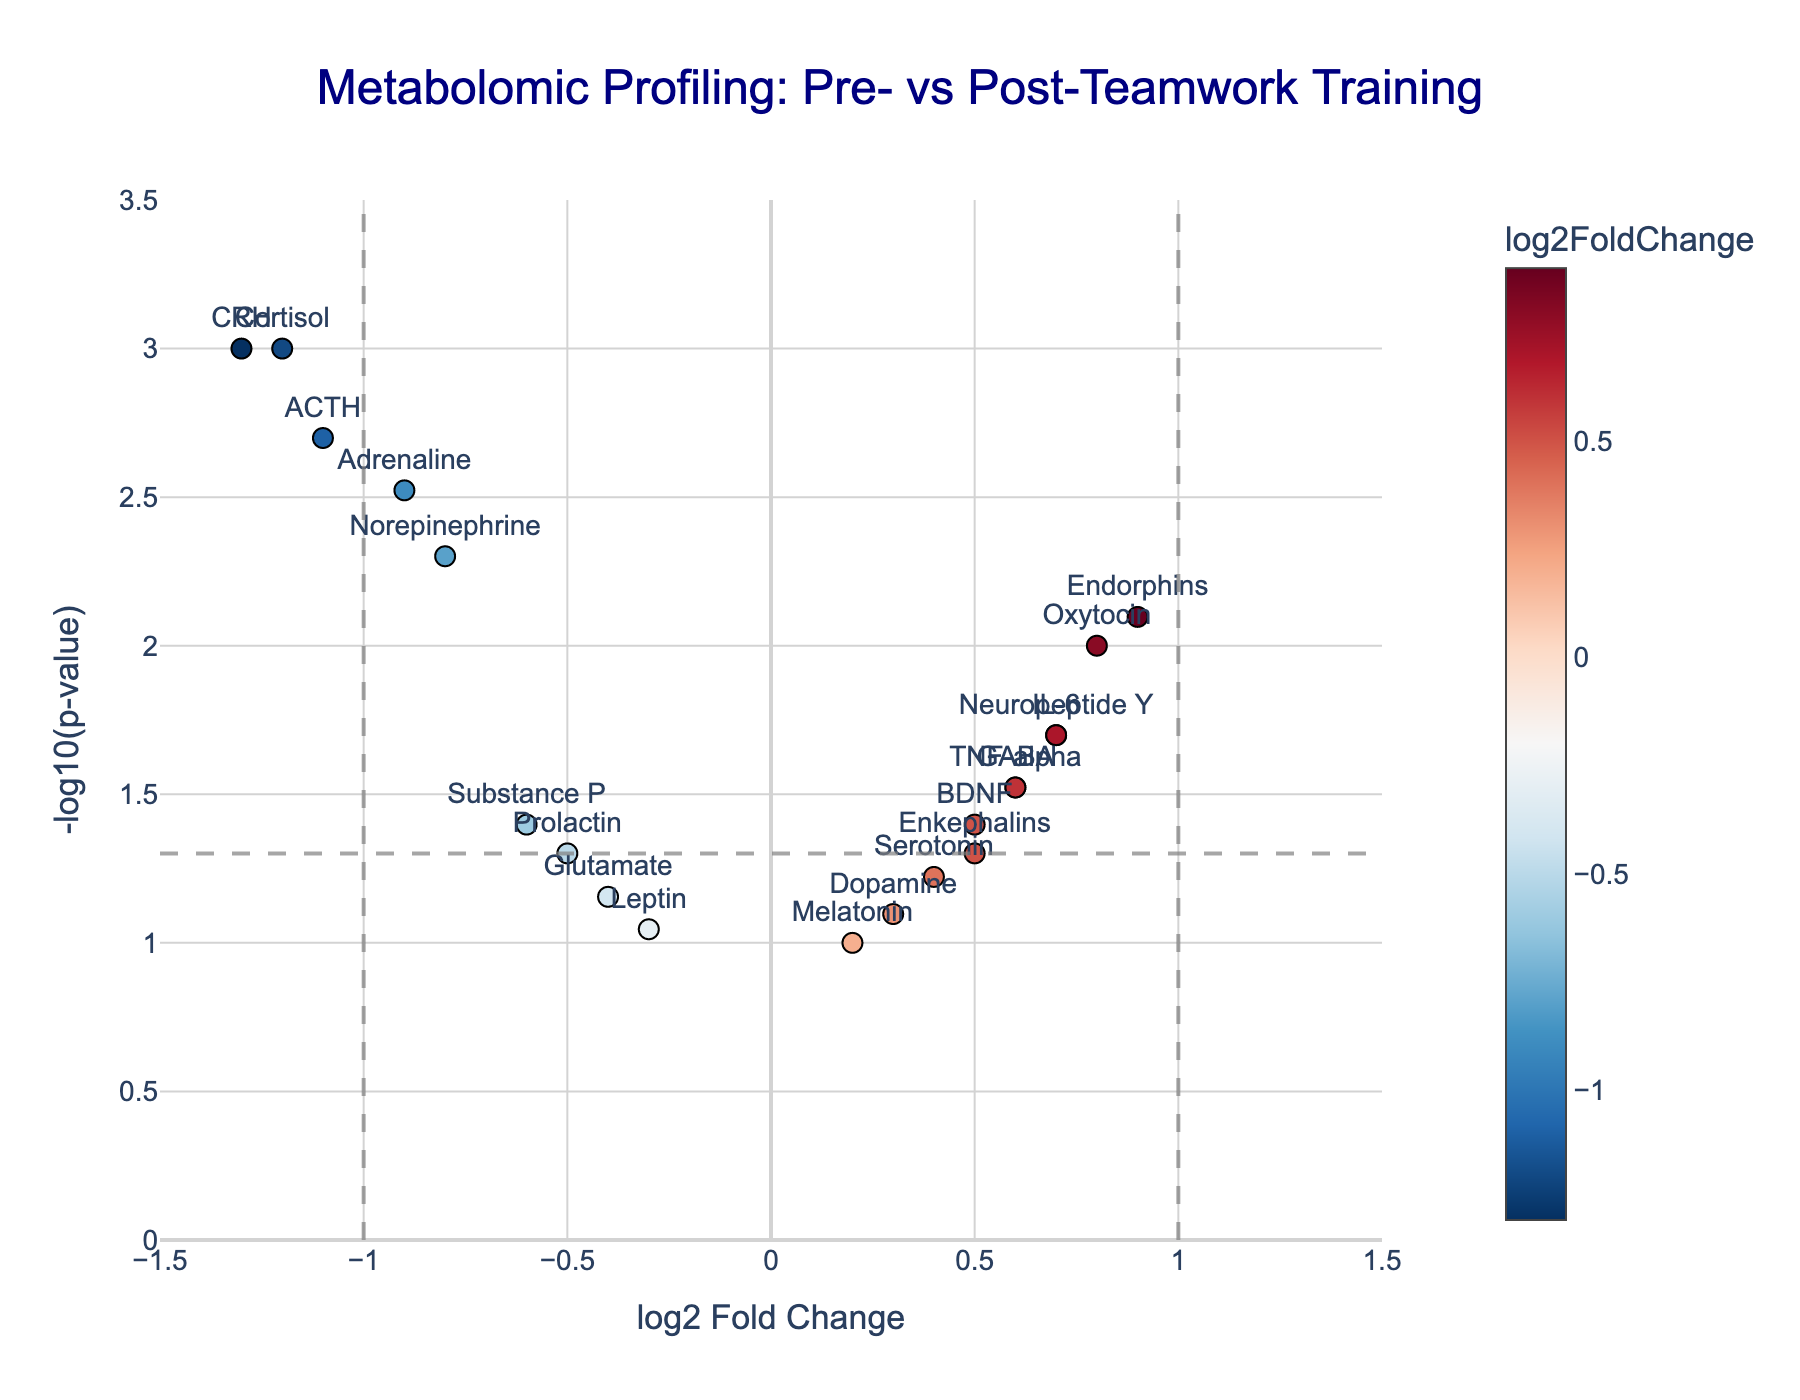How many genes show significant changes in stress levels after teamwork training? To determine significant changes, we look for points above the horizontal dashed line at -log10(p-value) = 1.3 (which corresponds to p-value < 0.05). From the figure, count the number of points above this line.
Answer: 11 Which gene had the highest decrease in stress levels? The gene with the highest decrease in stress levels will have the most negative log2FoldChange and be significantly different (above the horizontal line). Identify the lowest log2FoldChange value among significant points.
Answer: CRH What is the log2 fold change value for Oxytocin? Locate the point labeled Oxytocin on the plot and identify its position on the x-axis. The x-axis represents log2FoldChange values.
Answer: 0.8 How many genes have a log2FoldChange greater than 0.5? Count the number of points to the right of the x = 0.5 line where the log2FoldChange is greater than 0.5.
Answer: 3 Which gene has the lowest p-value? The lowest p-value corresponds to the highest -log10(p-value) on the y-axis. Identify the point at the highest position on the y-axis.
Answer: Cortisol Which stress-related gene did not reach statistical significance after teamwork training? To determine statistical significance, look for points below the -log10(p-value) = 1.3 dashed line. Identify the genes labeled on these points.
Answer: Dopamine Compare the log2FoldChange of Adrenaline and Norepinephrine. Which one shows a greater reduction in stress levels? Compare the x-axis positions of Adrenaline (-0.9) and Norepinephrine (-0.8). The more negative the log2FoldChange, the greater the reduction.
Answer: Adrenaline How many genes have a p-value less than 0.01? Points with p-values less than 0.01 will be above -log10(p-value) = 2 on the y-axis. Count the number of points above this level.
Answer: 4 Which gene has a higher fold change, BDNF or Enkephalins? Compare the x-axis values of BDNF (0.5) and Enkephalins (0.5). Determine which one is higher; since they are equal, state that.
Answer: Both are equal What is the title of the figure? Look at the text at the top of the figure. The title generally provides context for the data presented.
Answer: Metabolomic Profiling: Pre- vs Post-Teamwork Training 